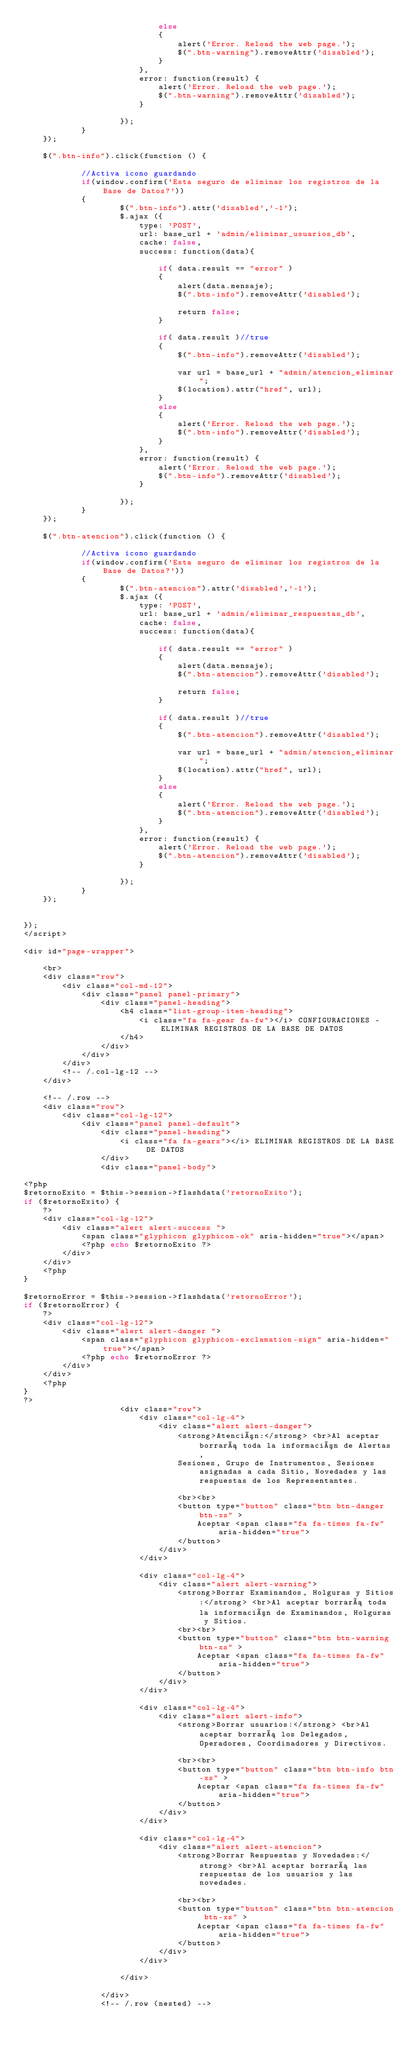Convert code to text. <code><loc_0><loc_0><loc_500><loc_500><_PHP_>							else
							{
								alert('Error. Reload the web page.');
								$(".btn-warning").removeAttr('disabled');
							}	
						},
						error: function(result) {
							alert('Error. Reload the web page.');
							$(".btn-warning").removeAttr('disabled');
						}

					});
			}
	});
	
	$(".btn-info").click(function () {	
			
			//Activa icono guardando
			if(window.confirm('Esta seguro de eliminar los registros de la Base de Datos?'))
			{
					$(".btn-info").attr('disabled','-1');
					$.ajax ({
						type: 'POST',
						url: base_url + 'admin/eliminar_usuarios_db',
						cache: false,
						success: function(data){
												
							if( data.result == "error" )
							{
								alert(data.mensaje);
								$(".btn-info").removeAttr('disabled');							
								return false;
							} 
											
							if( data.result )//true
							{	                                                        
								$(".btn-info").removeAttr('disabled');

								var url = base_url + "admin/atencion_eliminar";
								$(location).attr("href", url);
							}
							else
							{
								alert('Error. Reload the web page.');
								$(".btn-info").removeAttr('disabled');
							}	
						},
						error: function(result) {
							alert('Error. Reload the web page.');
							$(".btn-info").removeAttr('disabled');
						}

					});
			}
	});
	
	$(".btn-atencion").click(function () {	
			
			//Activa icono guardando
			if(window.confirm('Esta seguro de eliminar los registros de la Base de Datos?'))
			{
					$(".btn-atencion").attr('disabled','-1');
					$.ajax ({
						type: 'POST',
						url: base_url + 'admin/eliminar_respuestas_db',
						cache: false,
						success: function(data){
												
							if( data.result == "error" )
							{
								alert(data.mensaje);
								$(".btn-atencion").removeAttr('disabled');							
								return false;
							} 
											
							if( data.result )//true
							{	                                                        
								$(".btn-atencion").removeAttr('disabled');

								var url = base_url + "admin/atencion_eliminar";
								$(location).attr("href", url);
							}
							else
							{
								alert('Error. Reload the web page.');
								$(".btn-atencion").removeAttr('disabled');
							}	
						},
						error: function(result) {
							alert('Error. Reload the web page.');
							$(".btn-atencion").removeAttr('disabled');
						}

					});
			}
	});
	
	
});
</script>

<div id="page-wrapper">

	<br>
	<div class="row">
		<div class="col-md-12">
			<div class="panel panel-primary">
				<div class="panel-heading">
					<h4 class="list-group-item-heading">
						<i class="fa fa-gear fa-fw"></i> CONFIGURACIONES - ELIMINAR REGISTROS DE LA BASE DE DATOS
					</h4>
				</div>
			</div>
		</div>
		<!-- /.col-lg-12 -->				
	</div>
	
	<!-- /.row -->
	<div class="row">
		<div class="col-lg-12">
			<div class="panel panel-default">
				<div class="panel-heading">
					<i class="fa fa-gears"></i> ELIMINAR REGISTROS DE LA BASE DE DATOS
				</div>
				<div class="panel-body">
				
<?php
$retornoExito = $this->session->flashdata('retornoExito');
if ($retornoExito) {
    ?>
	<div class="col-lg-12">	
		<div class="alert alert-success ">
			<span class="glyphicon glyphicon-ok" aria-hidden="true"></span>
			<?php echo $retornoExito ?>		
		</div>
	</div>
    <?php
}

$retornoError = $this->session->flashdata('retornoError');
if ($retornoError) {
    ?>
	<div class="col-lg-12">	
		<div class="alert alert-danger ">
			<span class="glyphicon glyphicon-exclamation-sign" aria-hidden="true"></span>
			<?php echo $retornoError ?>
		</div>
	</div>
    <?php
}
?> 
					<div class="row">
						<div class="col-lg-4">	
							<div class="alert alert-danger">
								<strong>Atención:</strong> <br>Al aceptar borrará toda la información de Alertas, 
								Sesiones, Grupo de Instrumentos, Sesiones asignadas a cada Sitio, Novedades y las respuestas de los Representantes.
								
								<br><br>
								<button type="button" class="btn btn-danger btn-xs" >
									Aceptar <span class="fa fa-times fa-fw" aria-hidden="true">
								</button>						
							</div>
						</div>

						<div class="col-lg-4">	
							<div class="alert alert-warning">
								<strong>Borrar Examinandos, Holguras y Sitios:</strong> <br>Al aceptar borrará toda la información de Examinandos, Holguras y Sitios.
								<br><br>
								<button type="button" class="btn btn-warning btn-xs" >
									Aceptar <span class="fa fa-times fa-fw" aria-hidden="true">
								</button>						
							</div>
						</div>
						
						<div class="col-lg-4">	
							<div class="alert alert-info">
								<strong>Borrar usuarios:</strong> <br>Al aceptar borrará los Delegados, Operadores, Coordinadores y Directivos.
								
								<br><br>
								<button type="button" class="btn btn-info btn-xs" >
									Aceptar <span class="fa fa-times fa-fw" aria-hidden="true">
								</button>						
							</div>
						</div>
						
						<div class="col-lg-4">	
							<div class="alert alert-atencion">
								<strong>Borrar Respuestas y Novedades:</strong> <br>Al aceptar borrará las respuestas de los usuarios y las novedades.
								
								<br><br>
								<button type="button" class="btn btn-atencion btn-xs" >
									Aceptar <span class="fa fa-times fa-fw" aria-hidden="true">
								</button>						
							</div>
						</div>
						
					</div>
					
				</div>
				<!-- /.row (nested) --></code> 